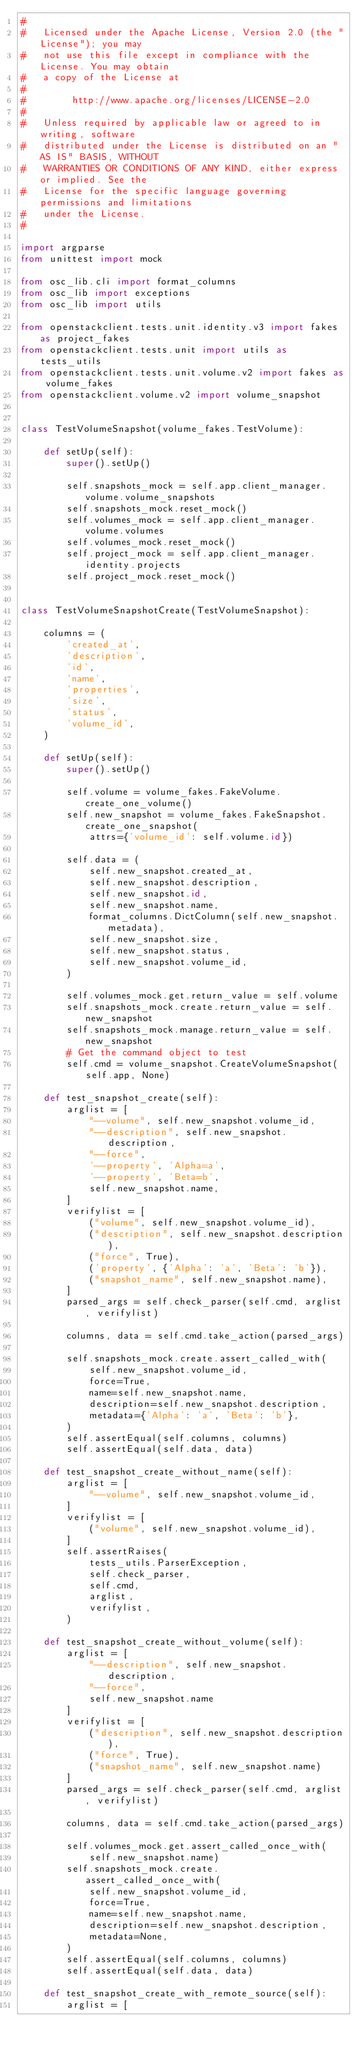<code> <loc_0><loc_0><loc_500><loc_500><_Python_>#
#   Licensed under the Apache License, Version 2.0 (the "License"); you may
#   not use this file except in compliance with the License. You may obtain
#   a copy of the License at
#
#        http://www.apache.org/licenses/LICENSE-2.0
#
#   Unless required by applicable law or agreed to in writing, software
#   distributed under the License is distributed on an "AS IS" BASIS, WITHOUT
#   WARRANTIES OR CONDITIONS OF ANY KIND, either express or implied. See the
#   License for the specific language governing permissions and limitations
#   under the License.
#

import argparse
from unittest import mock

from osc_lib.cli import format_columns
from osc_lib import exceptions
from osc_lib import utils

from openstackclient.tests.unit.identity.v3 import fakes as project_fakes
from openstackclient.tests.unit import utils as tests_utils
from openstackclient.tests.unit.volume.v2 import fakes as volume_fakes
from openstackclient.volume.v2 import volume_snapshot


class TestVolumeSnapshot(volume_fakes.TestVolume):

    def setUp(self):
        super().setUp()

        self.snapshots_mock = self.app.client_manager.volume.volume_snapshots
        self.snapshots_mock.reset_mock()
        self.volumes_mock = self.app.client_manager.volume.volumes
        self.volumes_mock.reset_mock()
        self.project_mock = self.app.client_manager.identity.projects
        self.project_mock.reset_mock()


class TestVolumeSnapshotCreate(TestVolumeSnapshot):

    columns = (
        'created_at',
        'description',
        'id',
        'name',
        'properties',
        'size',
        'status',
        'volume_id',
    )

    def setUp(self):
        super().setUp()

        self.volume = volume_fakes.FakeVolume.create_one_volume()
        self.new_snapshot = volume_fakes.FakeSnapshot.create_one_snapshot(
            attrs={'volume_id': self.volume.id})

        self.data = (
            self.new_snapshot.created_at,
            self.new_snapshot.description,
            self.new_snapshot.id,
            self.new_snapshot.name,
            format_columns.DictColumn(self.new_snapshot.metadata),
            self.new_snapshot.size,
            self.new_snapshot.status,
            self.new_snapshot.volume_id,
        )

        self.volumes_mock.get.return_value = self.volume
        self.snapshots_mock.create.return_value = self.new_snapshot
        self.snapshots_mock.manage.return_value = self.new_snapshot
        # Get the command object to test
        self.cmd = volume_snapshot.CreateVolumeSnapshot(self.app, None)

    def test_snapshot_create(self):
        arglist = [
            "--volume", self.new_snapshot.volume_id,
            "--description", self.new_snapshot.description,
            "--force",
            '--property', 'Alpha=a',
            '--property', 'Beta=b',
            self.new_snapshot.name,
        ]
        verifylist = [
            ("volume", self.new_snapshot.volume_id),
            ("description", self.new_snapshot.description),
            ("force", True),
            ('property', {'Alpha': 'a', 'Beta': 'b'}),
            ("snapshot_name", self.new_snapshot.name),
        ]
        parsed_args = self.check_parser(self.cmd, arglist, verifylist)

        columns, data = self.cmd.take_action(parsed_args)

        self.snapshots_mock.create.assert_called_with(
            self.new_snapshot.volume_id,
            force=True,
            name=self.new_snapshot.name,
            description=self.new_snapshot.description,
            metadata={'Alpha': 'a', 'Beta': 'b'},
        )
        self.assertEqual(self.columns, columns)
        self.assertEqual(self.data, data)

    def test_snapshot_create_without_name(self):
        arglist = [
            "--volume", self.new_snapshot.volume_id,
        ]
        verifylist = [
            ("volume", self.new_snapshot.volume_id),
        ]
        self.assertRaises(
            tests_utils.ParserException,
            self.check_parser,
            self.cmd,
            arglist,
            verifylist,
        )

    def test_snapshot_create_without_volume(self):
        arglist = [
            "--description", self.new_snapshot.description,
            "--force",
            self.new_snapshot.name
        ]
        verifylist = [
            ("description", self.new_snapshot.description),
            ("force", True),
            ("snapshot_name", self.new_snapshot.name)
        ]
        parsed_args = self.check_parser(self.cmd, arglist, verifylist)

        columns, data = self.cmd.take_action(parsed_args)

        self.volumes_mock.get.assert_called_once_with(
            self.new_snapshot.name)
        self.snapshots_mock.create.assert_called_once_with(
            self.new_snapshot.volume_id,
            force=True,
            name=self.new_snapshot.name,
            description=self.new_snapshot.description,
            metadata=None,
        )
        self.assertEqual(self.columns, columns)
        self.assertEqual(self.data, data)

    def test_snapshot_create_with_remote_source(self):
        arglist = [</code> 